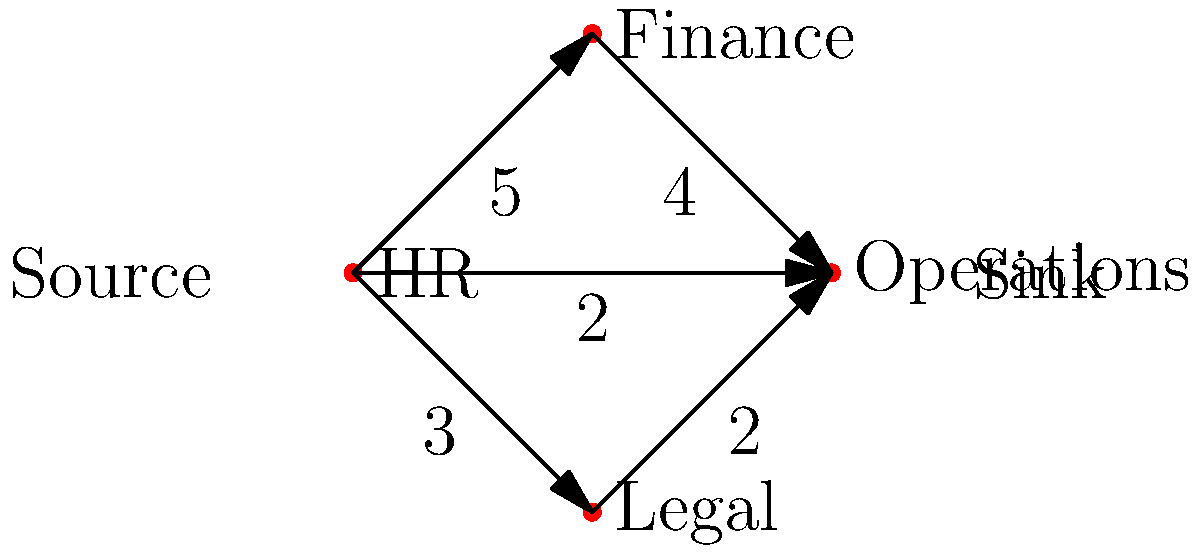In a large corporation, document access between departments is modeled as a network flow problem. The diagram shows the maximum number of documents that can be transferred between departments per hour. What is the maximum number of documents that can flow from HR (the source) to Operations (the sink) per hour? To solve this network flow problem, we'll use the Ford-Fulkerson algorithm:

1. Identify all possible paths from source (HR) to sink (Operations):
   Path 1: HR -> Operations (capacity 2)
   Path 2: HR -> Finance -> Operations (capacity min(5,4) = 4)
   Path 3: HR -> Legal -> Operations (capacity min(3,2) = 2)

2. Start with the path of highest capacity:
   Path 2: HR -> Finance -> Operations (4 documents)
   Remaining capacities: HR->Finance: 1, Finance->Operations: 0

3. Find the next available path:
   Path 1: HR -> Operations (2 documents)
   Remaining capacities: HR->Operations: 0

4. Check the last path:
   Path 3: HR -> Legal -> Operations (2 documents)
   Remaining capacities: HR->Legal: 1, Legal->Operations: 0

5. Sum up the flows:
   4 + 2 + 2 = 8 documents per hour

Therefore, the maximum flow from HR to Operations is 8 documents per hour.
Answer: 8 documents per hour 